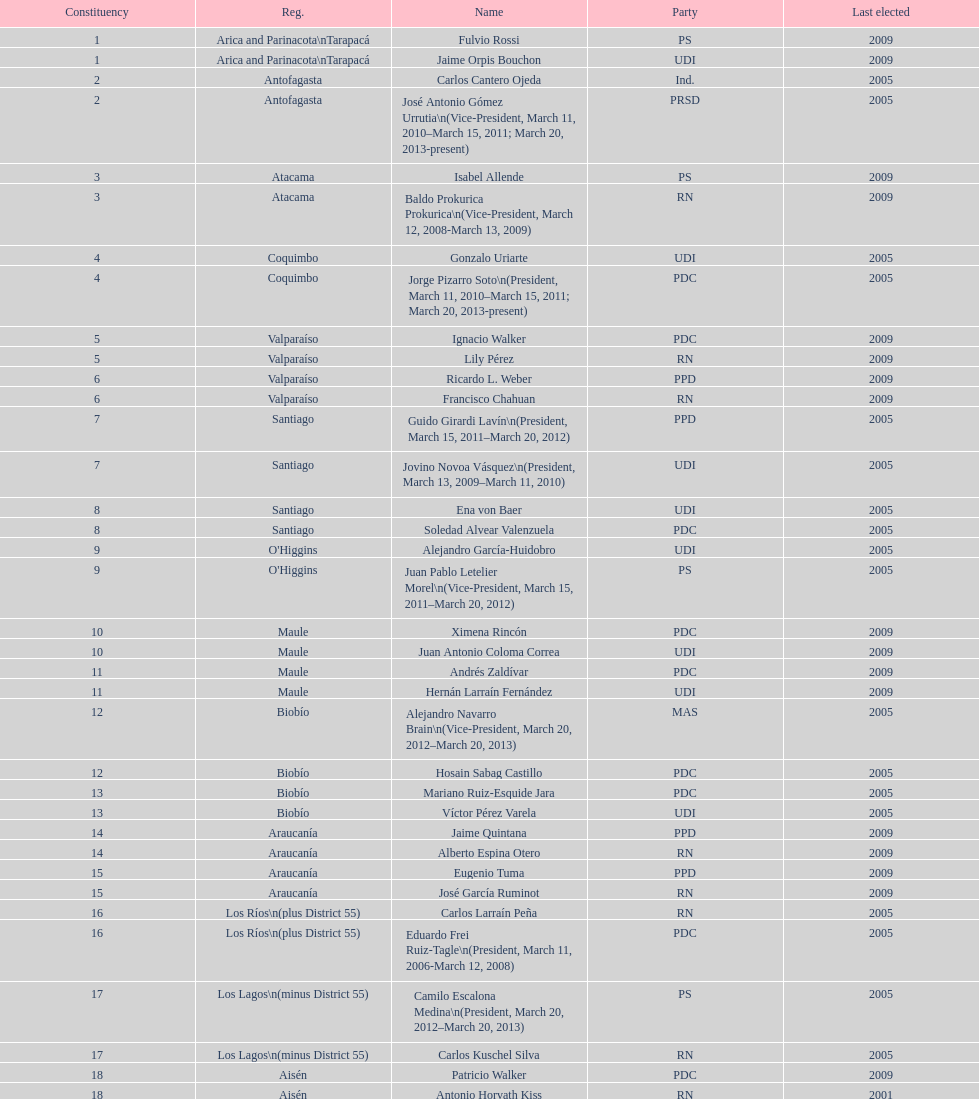How many total consituency are listed in the table? 19. 